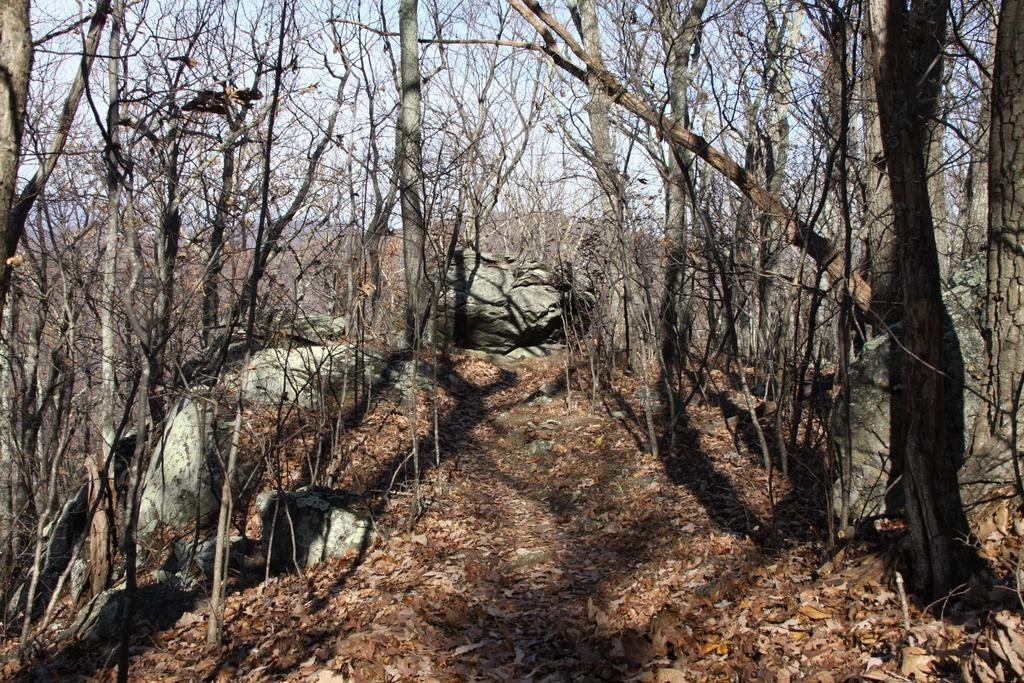What type of natural elements can be seen in the image? There are trees and rocks in the image. What is visible in the background of the image? The sky and mountains are visible in the background of the image. What is present at the bottom of the image? Dry leaves and a walkway are present at the bottom of the image. Can you see an uncle sneezing on a boat in the image? There is no uncle or boat present in the image. 